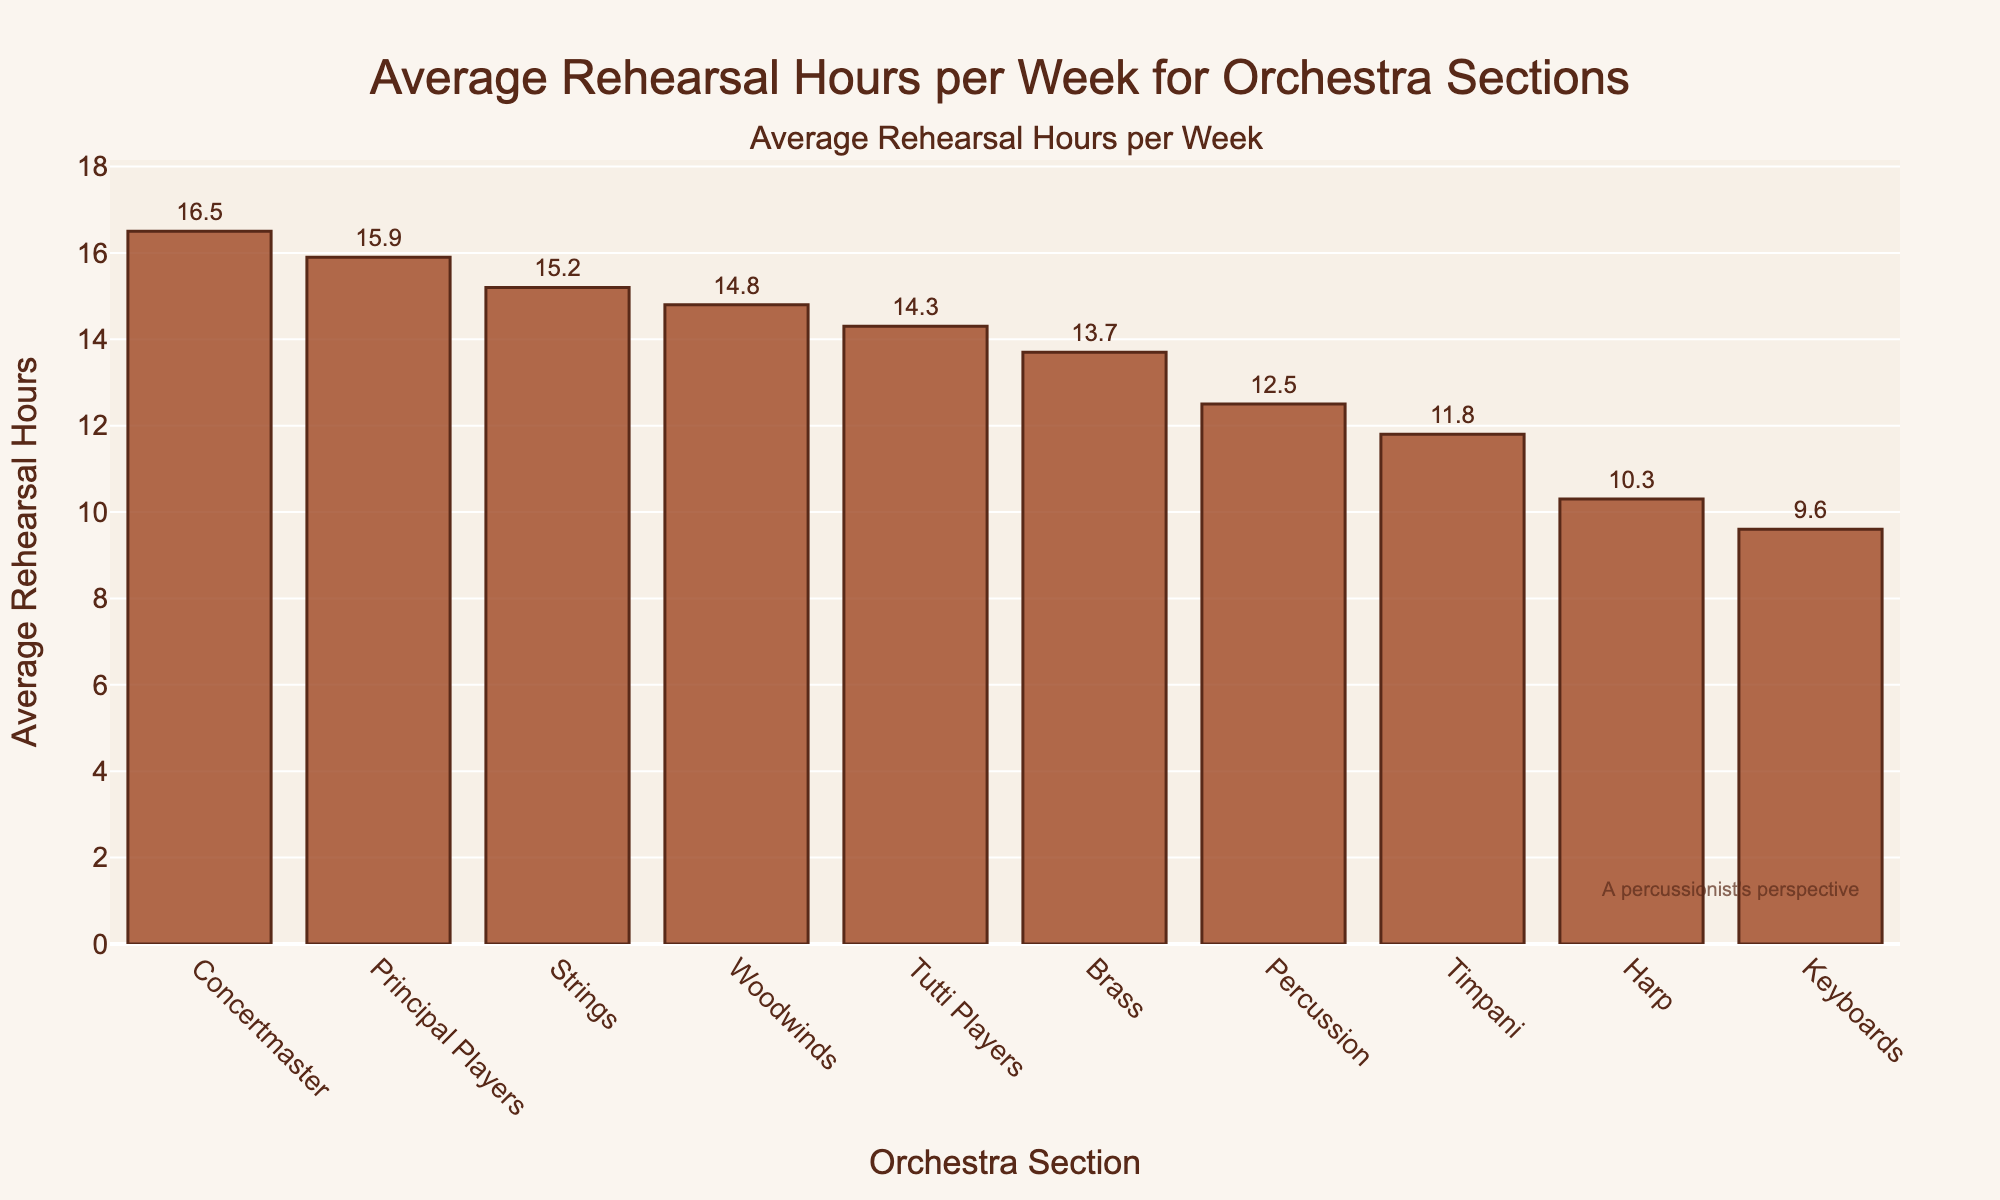Which section has the highest average rehearsal hours per week? The section with the highest bar represents the highest average rehearsal hours. The Concertmaster section has the highest bar, indicating they have the highest average rehearsal hours per week.
Answer: Concertmaster Which section has the lowest average rehearsal hours per week? The section with the lowest bar indicates the lowest average rehearsal hours. The Keyboards section has the lowest bar.
Answer: Keyboards How much more average rehearsal hours does the Concertmaster have compared to the Harp section? Locate the average rehearsal hours for both the Concertmaster and Harp sections. Subtract the Harp's hours (10.3) from the Concertmaster's hours (16.5). 16.5 - 10.3 = 6.2.
Answer: 6.2 What is the combined average rehearsal hours of the Percussion and Timpani sections? Find the average rehearsal hours for both Percussion and Timpani sections and add them together. Percussion has 12.5 and Timpani has 11.8. 12.5 + 11.8 = 24.3
Answer: 24.3 Is the average rehearsal hours of the Principal Players section more or less compared to the Strings section? Compare the bar heights of the Principal Players and Strings sections. The Principal Players have 15.9 hours, and the Strings have 15.2 hours. Principal Players have more hours.
Answer: More Which sections have an average rehearsal time between 10 and 15 hours? Find and list the sections whose bars correspond to values between 10 and 15 on the y-axis. The sections are Percussion (12.5), Woodwinds (14.8), Brass (13.7), Harp (10.3), and Timpani (11.8).
Answer: Percussion, Woodwinds, Brass, Harp, Timpani How many hours in total do the sections with less than 12 hours average rehearsal time accumulate? Identify sections with less than 12 hours average rehearsal time: Harp (10.3) and Keyboards (9.6). Sum their hours. 10.3 + 9.6 = 19.9
Answer: 19.9 What’s the difference in average rehearsal hours between Tutti Players and Principal Players? Locate the average rehearsal hours for Tutti Players (14.3) and Principal Players (15.9). Subtract Tutti Players' average from Principal Players' average. 15.9 - 14.3 = 1.6
Answer: 1.6 